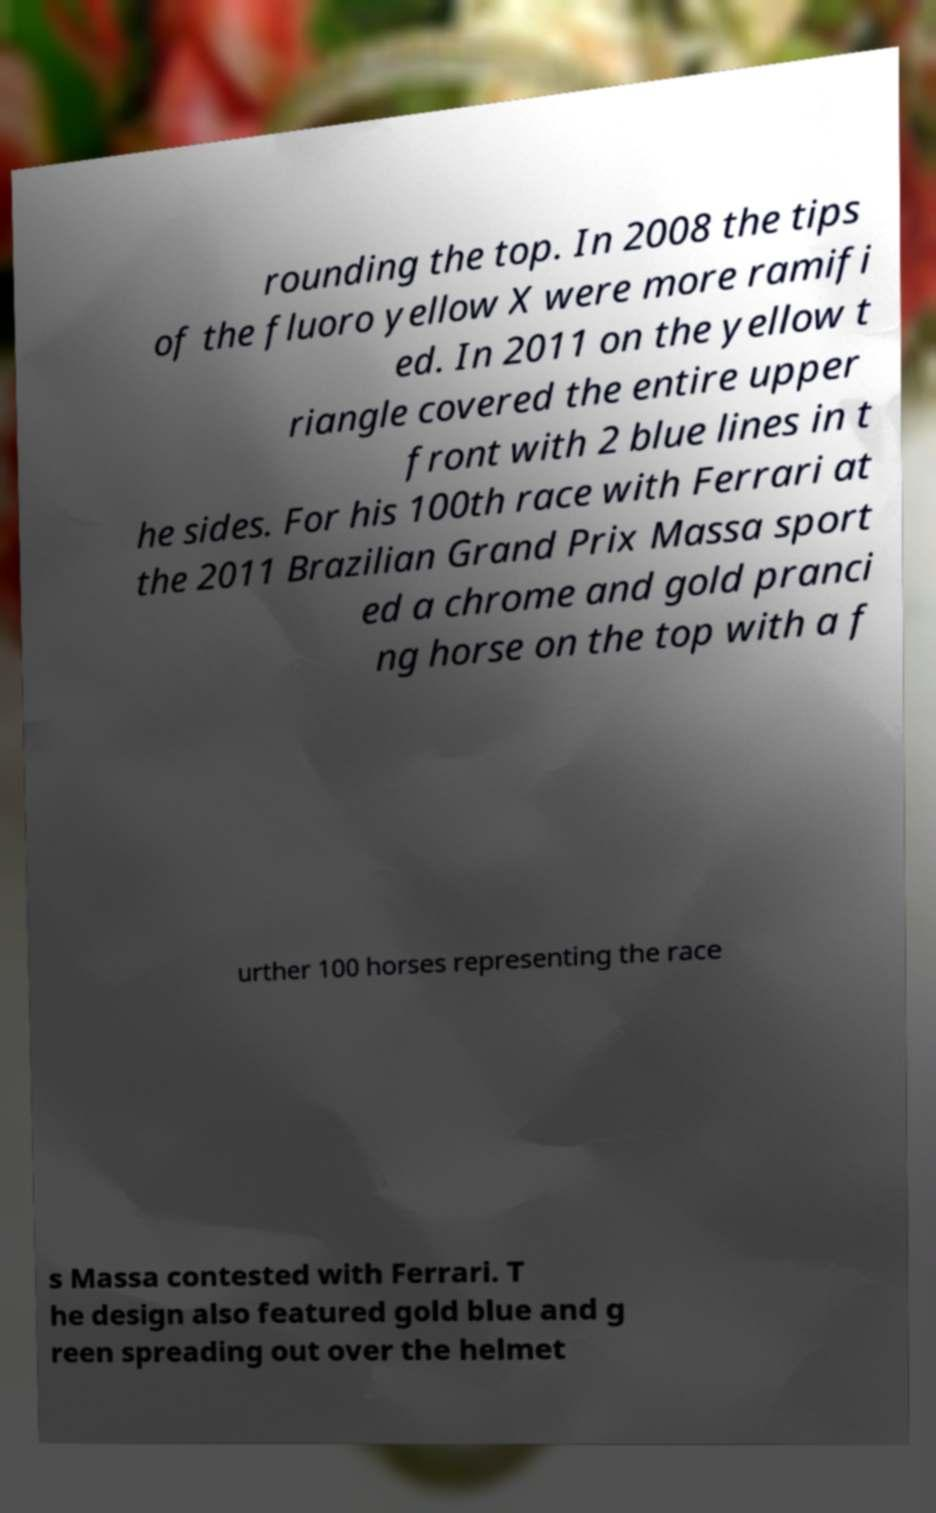Please read and relay the text visible in this image. What does it say? rounding the top. In 2008 the tips of the fluoro yellow X were more ramifi ed. In 2011 on the yellow t riangle covered the entire upper front with 2 blue lines in t he sides. For his 100th race with Ferrari at the 2011 Brazilian Grand Prix Massa sport ed a chrome and gold pranci ng horse on the top with a f urther 100 horses representing the race s Massa contested with Ferrari. T he design also featured gold blue and g reen spreading out over the helmet 